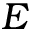Convert formula to latex. <formula><loc_0><loc_0><loc_500><loc_500>E</formula> 